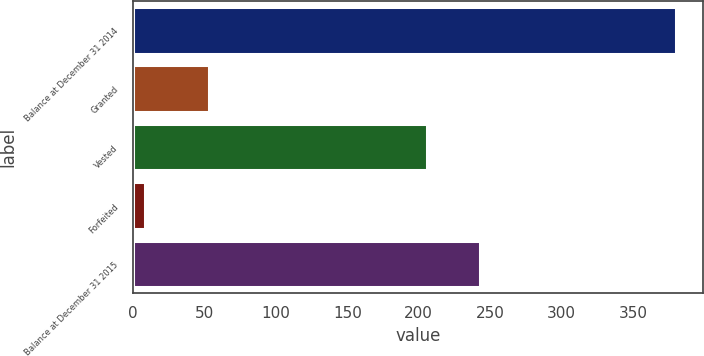Convert chart to OTSL. <chart><loc_0><loc_0><loc_500><loc_500><bar_chart><fcel>Balance at December 31 2014<fcel>Granted<fcel>Vested<fcel>Forfeited<fcel>Balance at December 31 2015<nl><fcel>380<fcel>53<fcel>206<fcel>8<fcel>243.2<nl></chart> 